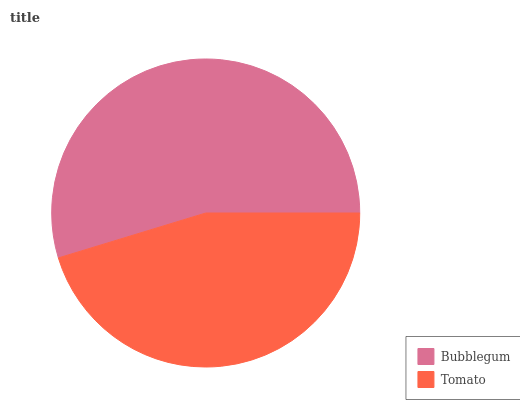Is Tomato the minimum?
Answer yes or no. Yes. Is Bubblegum the maximum?
Answer yes or no. Yes. Is Tomato the maximum?
Answer yes or no. No. Is Bubblegum greater than Tomato?
Answer yes or no. Yes. Is Tomato less than Bubblegum?
Answer yes or no. Yes. Is Tomato greater than Bubblegum?
Answer yes or no. No. Is Bubblegum less than Tomato?
Answer yes or no. No. Is Bubblegum the high median?
Answer yes or no. Yes. Is Tomato the low median?
Answer yes or no. Yes. Is Tomato the high median?
Answer yes or no. No. Is Bubblegum the low median?
Answer yes or no. No. 